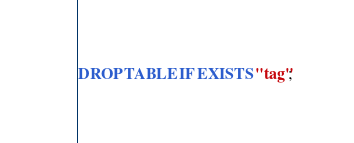<code> <loc_0><loc_0><loc_500><loc_500><_SQL_>DROP TABLE IF EXISTS "tag";</code> 